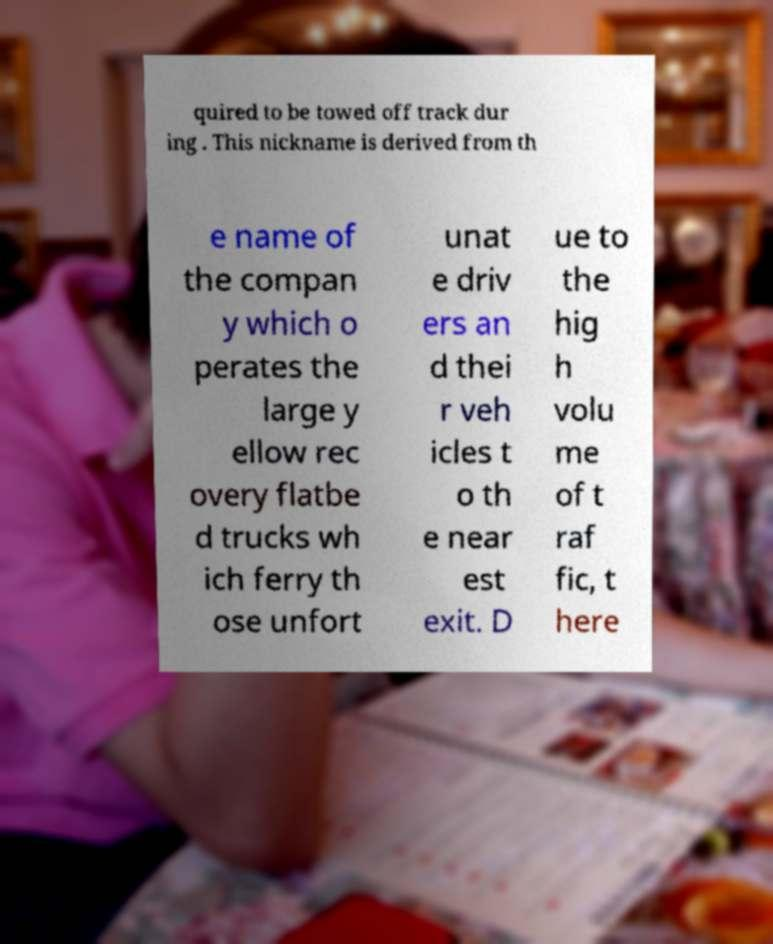I need the written content from this picture converted into text. Can you do that? quired to be towed off track dur ing . This nickname is derived from th e name of the compan y which o perates the large y ellow rec overy flatbe d trucks wh ich ferry th ose unfort unat e driv ers an d thei r veh icles t o th e near est exit. D ue to the hig h volu me of t raf fic, t here 